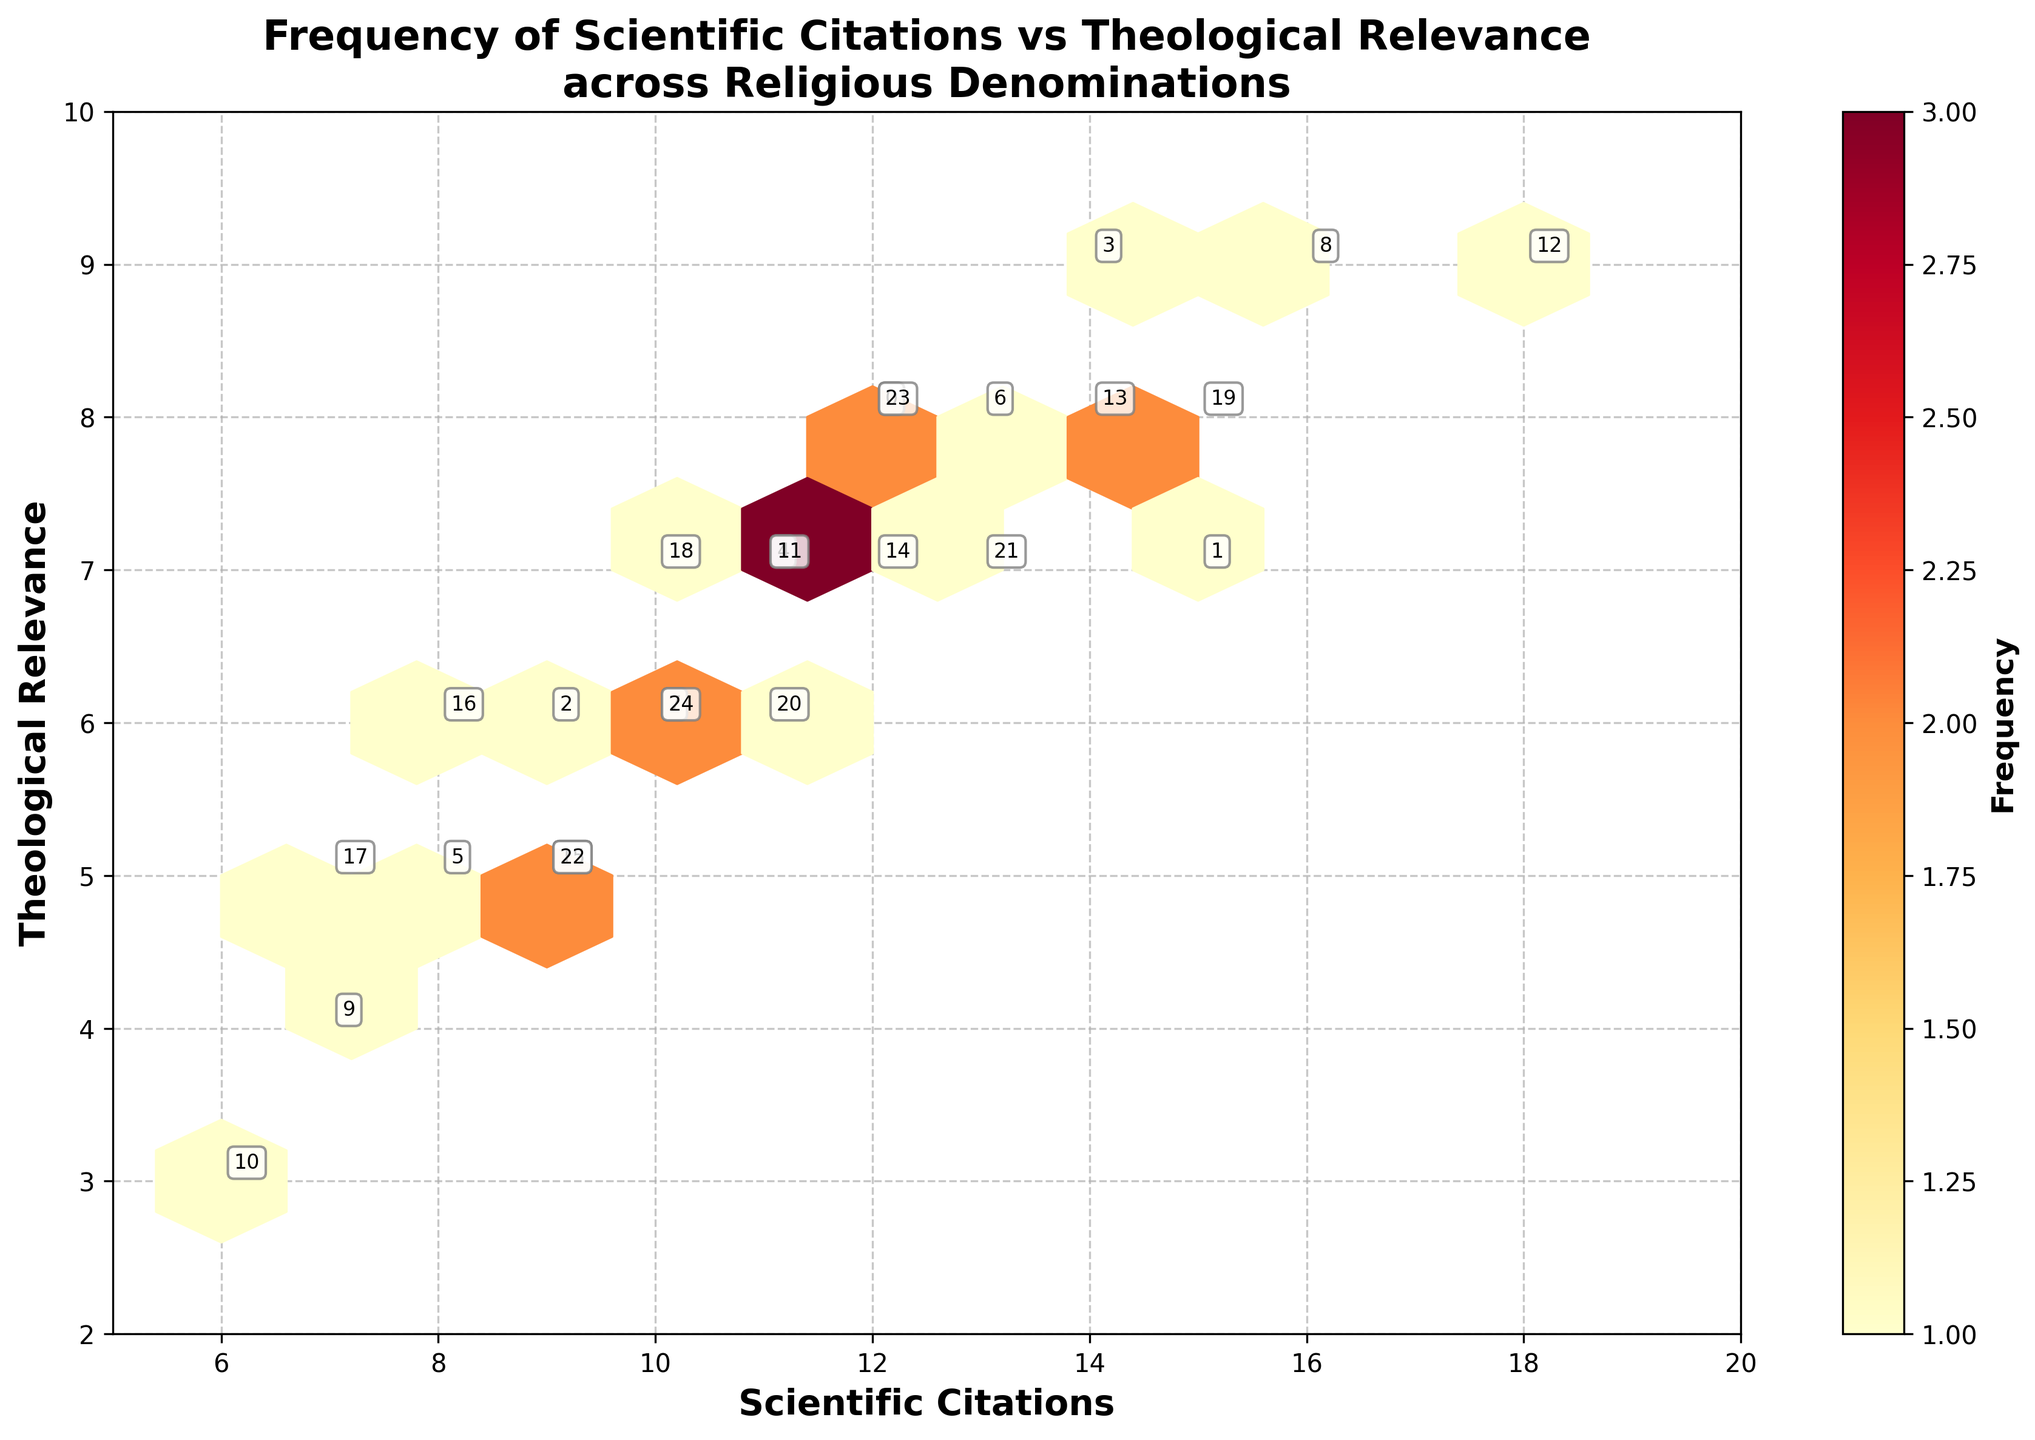what is the title of the plot? The title is written at the top of the plot in a bold and larger font than the other text. It is divided into two lines for better readability.
Answer: Frequency of Scientific Citations vs Theological Relevance across Religious Denominations What are the axes labeled? The labels of the axes are written next to them. The x-axis is horizontally labeled along the bottom, and the y-axis is vertically labeled along the left side of the plot.
Answer: The x-axis is labeled 'Scientific Citations' and the y-axis is labeled 'Theological Relevance' Which denomination appears to have the highest theological relevance? To find this, look at the topmost points on the y-axis. Identify the denomination labeled closest to the y-axis value of 9.
Answer: Anglican, Seventh-day Adventist, Unitarian Universalist How many denominations are there with scientific citations greater than or equal to 15? First, identify which grid cells on the x-axis are equal to or greater than 15. Count the denominations falling within those grids.
Answer: 3 (Protestant, Seventh-day Adventist, Baha'i Faith) Which two denominations have the same value for both scientific citations and theological relevance? Look at the plot and identify denominations that have overlapping points, indicating identical x and y values.
Answer: Eastern Orthodox and Orthodox Judaism (9, 6) What theological relevance value is most frequently represented across different denominations? Observe the color density (hexbin grid) to determine which y-value range appears most frequently. Denser colors indicate higher frequency.
Answer: 6 and 7 What is the relationship between scientific citations and theological relevance for denominations with exactly 12 citations? Identify points at an x value of 12 and observe their corresponding y values.
Answer: (Catholic, Taoism): 8 and (Conservative Judaism): 7 Compare the theological relevance of denominations with the highest and lowest scientific citations. First, identify the denomination with the highest and lowest x values. Then, compare their y values (theological relevance).
Answer: Unitarian Universalist (18, 9) and Jehovah's Witnesses (6, 3) What color is used for the highest frequency in the hexbin plot? Observe the color key or color bar adjacent to the plot. The color indicating the highest frequency will usually be at the end of the spectrum.
Answer: Darker shade in the corresponding color map (YlOrRd, typically dark red) Do denominations with scientific citations between 10 and 15 generally have higher theological relevance than those with less than 10 citations? Compare the y-values (theological relevance) of denominations within the specified range to those below it on the plot.
Answer: Yes, denominations within 10-15 citations tend to cluster around higher y-values 